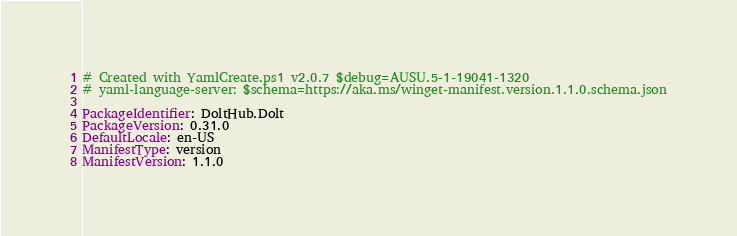Convert code to text. <code><loc_0><loc_0><loc_500><loc_500><_YAML_># Created with YamlCreate.ps1 v2.0.7 $debug=AUSU.5-1-19041-1320
# yaml-language-server: $schema=https://aka.ms/winget-manifest.version.1.1.0.schema.json

PackageIdentifier: DoltHub.Dolt
PackageVersion: 0.31.0
DefaultLocale: en-US
ManifestType: version
ManifestVersion: 1.1.0
</code> 